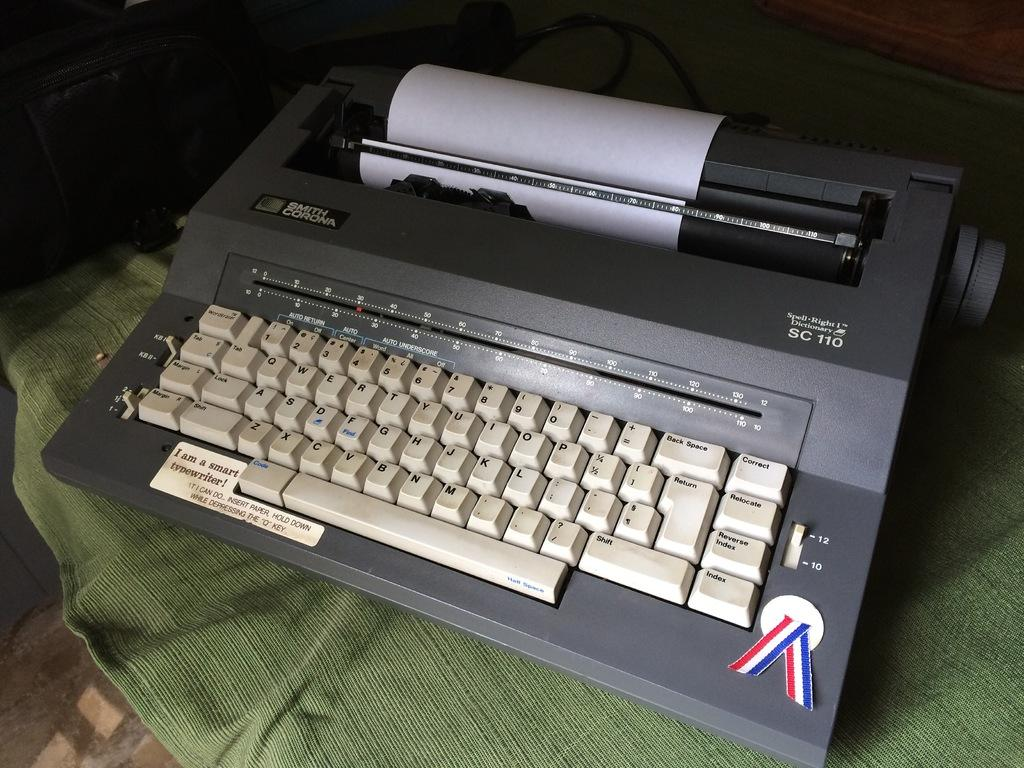Provide a one-sentence caption for the provided image. The SC 110 typewriter is made by Smith Corona. 